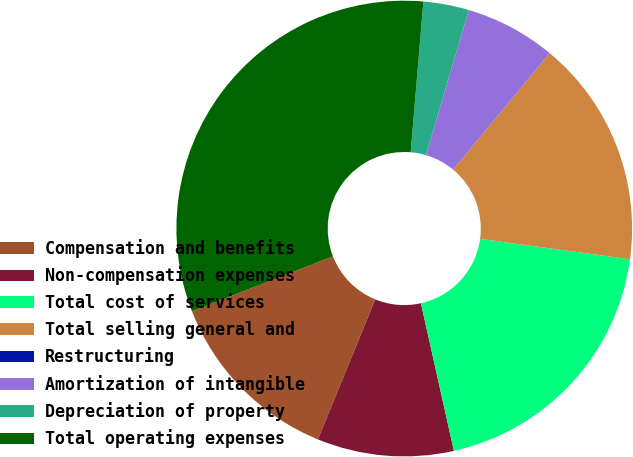Convert chart to OTSL. <chart><loc_0><loc_0><loc_500><loc_500><pie_chart><fcel>Compensation and benefits<fcel>Non-compensation expenses<fcel>Total cost of services<fcel>Total selling general and<fcel>Restructuring<fcel>Amortization of intangible<fcel>Depreciation of property<fcel>Total operating expenses<nl><fcel>12.9%<fcel>9.68%<fcel>19.35%<fcel>16.13%<fcel>0.0%<fcel>6.45%<fcel>3.23%<fcel>32.25%<nl></chart> 